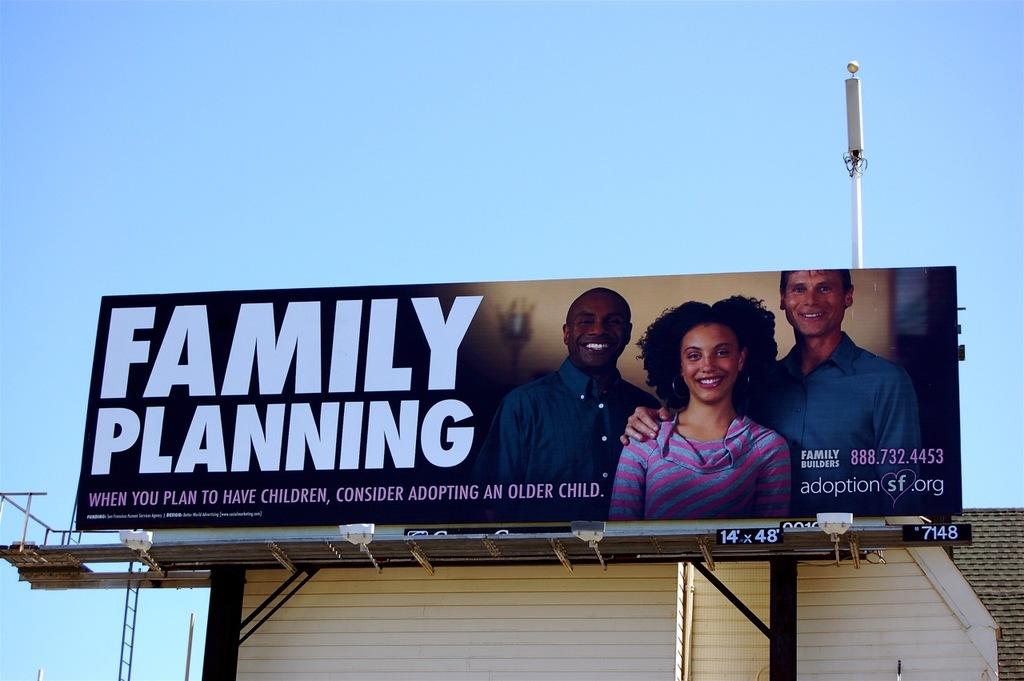Is this sign about adoption in san fransisco?
Your answer should be very brief. Yes. 